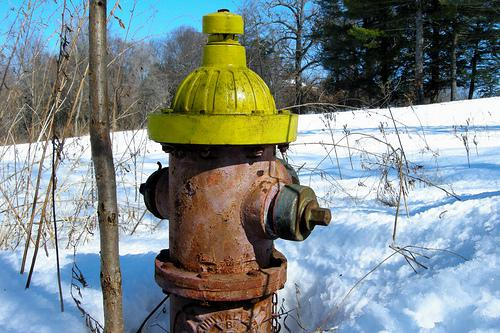Question: where is this taking place?
Choices:
A. A park.
B. A zoo.
C. A beach.
D. Outdoors.
Answer with the letter. Answer: D Question: what condition is the bottom of the fire hydrant in?
Choices:
A. Corroded.
B. Needs paint.
C. Poor.
D. Rusty.
Answer with the letter. Answer: D Question: what season is this?
Choices:
A. Winter.
B. Summer.
C. Fall.
D. Spring.
Answer with the letter. Answer: A Question: what are the objects in the background?
Choices:
A. Mountains.
B. Cars.
C. Trees.
D. Buildings.
Answer with the letter. Answer: C Question: how many people are in the photo?
Choices:
A. Four.
B. Several.
C. None.
D. A couple.
Answer with the letter. Answer: C 